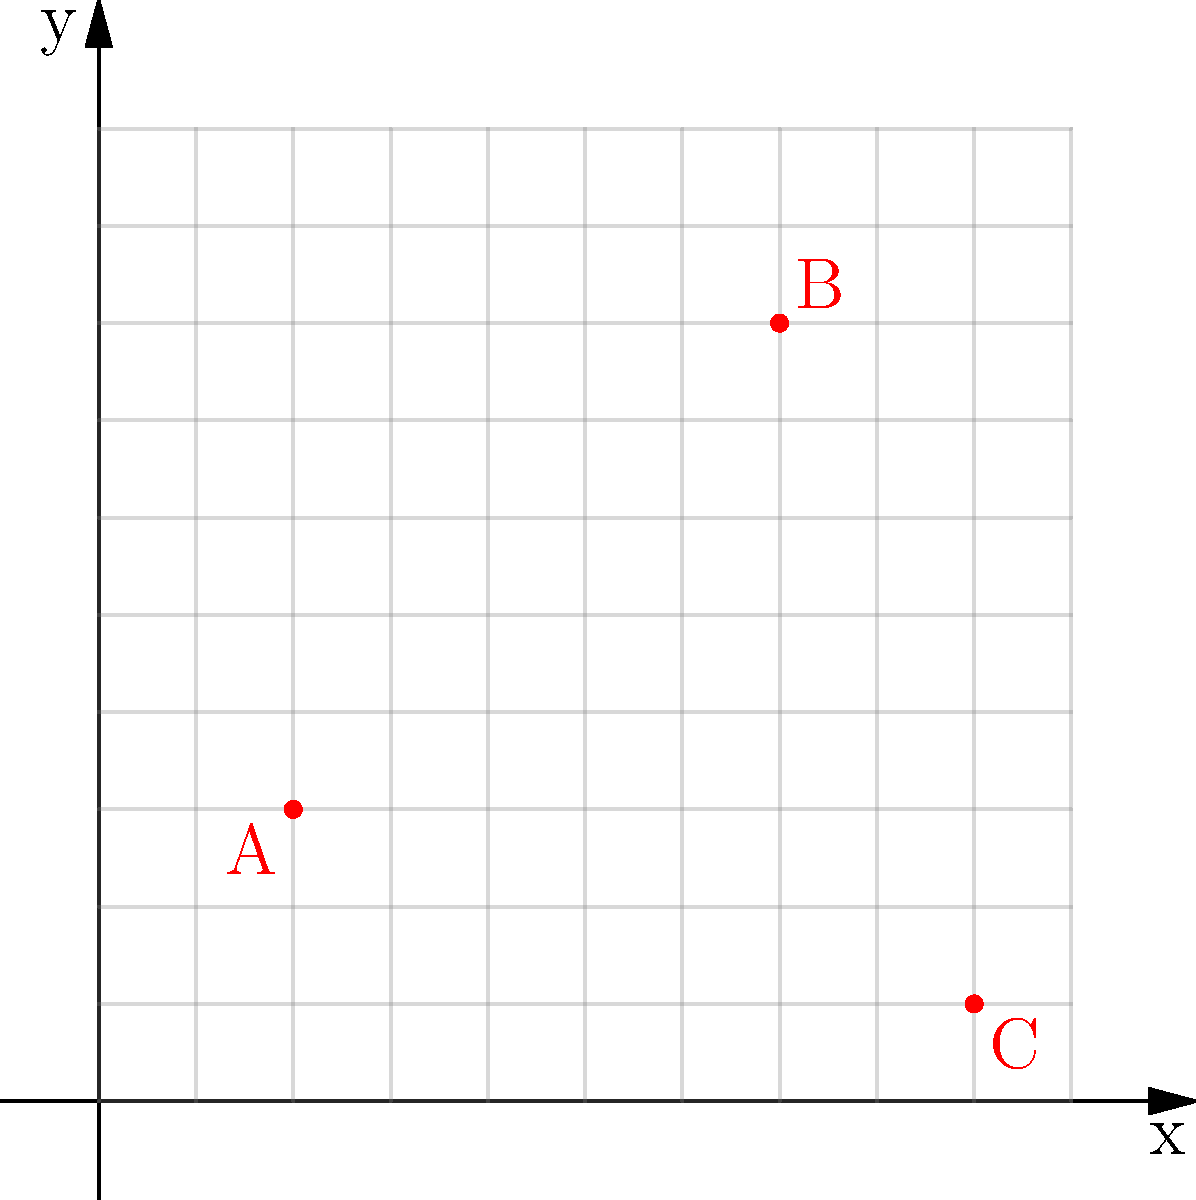In a city block, three surveillance cameras (A, B, and C) are positioned as shown in the coordinate grid above. If a crime occurs at the midpoint between cameras A and B, what are the coordinates of the crime scene? To find the midpoint between cameras A and B, we need to:

1. Identify the coordinates of A and B:
   Camera A: $(2, 3)$
   Camera B: $(7, 8)$

2. Use the midpoint formula: $(\frac{x_1 + x_2}{2}, \frac{y_1 + y_2}{2})$

3. Calculate the x-coordinate of the midpoint:
   $x = \frac{2 + 7}{2} = \frac{9}{2} = 4.5$

4. Calculate the y-coordinate of the midpoint:
   $y = \frac{3 + 8}{2} = \frac{11}{2} = 5.5$

5. The coordinates of the crime scene (midpoint) are $(4.5, 5.5)$

This method allows investigators to pinpoint the exact location of the crime scene based on the relative positions of the surveillance cameras.
Answer: $(4.5, 5.5)$ 